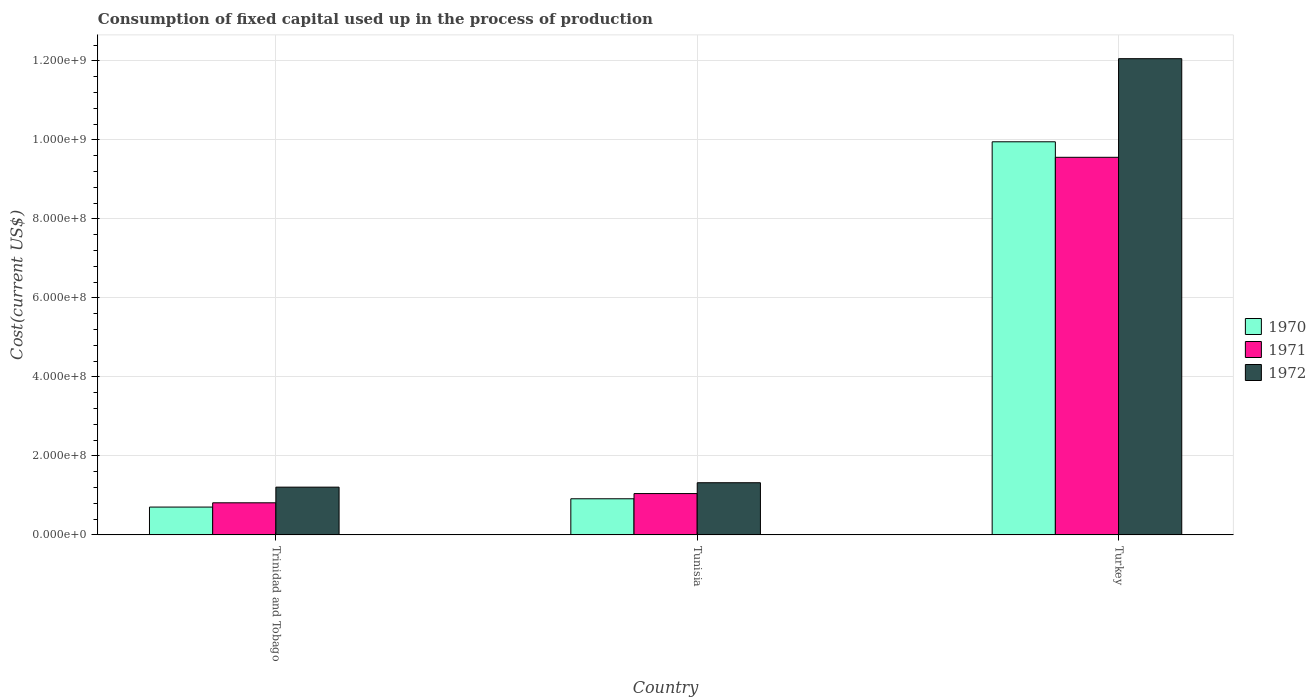How many different coloured bars are there?
Offer a terse response. 3. Are the number of bars on each tick of the X-axis equal?
Make the answer very short. Yes. How many bars are there on the 2nd tick from the right?
Provide a short and direct response. 3. What is the label of the 2nd group of bars from the left?
Your answer should be compact. Tunisia. What is the amount consumed in the process of production in 1972 in Turkey?
Your answer should be compact. 1.21e+09. Across all countries, what is the maximum amount consumed in the process of production in 1972?
Your response must be concise. 1.21e+09. Across all countries, what is the minimum amount consumed in the process of production in 1972?
Offer a very short reply. 1.21e+08. In which country was the amount consumed in the process of production in 1972 minimum?
Provide a succinct answer. Trinidad and Tobago. What is the total amount consumed in the process of production in 1971 in the graph?
Give a very brief answer. 1.14e+09. What is the difference between the amount consumed in the process of production in 1972 in Trinidad and Tobago and that in Tunisia?
Offer a very short reply. -1.12e+07. What is the difference between the amount consumed in the process of production in 1971 in Trinidad and Tobago and the amount consumed in the process of production in 1970 in Tunisia?
Make the answer very short. -1.02e+07. What is the average amount consumed in the process of production in 1970 per country?
Provide a short and direct response. 3.86e+08. What is the difference between the amount consumed in the process of production of/in 1972 and amount consumed in the process of production of/in 1970 in Tunisia?
Provide a short and direct response. 4.06e+07. In how many countries, is the amount consumed in the process of production in 1972 greater than 1160000000 US$?
Your answer should be compact. 1. What is the ratio of the amount consumed in the process of production in 1971 in Trinidad and Tobago to that in Turkey?
Your answer should be compact. 0.09. What is the difference between the highest and the second highest amount consumed in the process of production in 1972?
Provide a succinct answer. 1.08e+09. What is the difference between the highest and the lowest amount consumed in the process of production in 1970?
Offer a very short reply. 9.25e+08. Is the sum of the amount consumed in the process of production in 1971 in Trinidad and Tobago and Tunisia greater than the maximum amount consumed in the process of production in 1972 across all countries?
Give a very brief answer. No. What does the 3rd bar from the left in Trinidad and Tobago represents?
Provide a succinct answer. 1972. Are all the bars in the graph horizontal?
Your response must be concise. No. Are the values on the major ticks of Y-axis written in scientific E-notation?
Offer a very short reply. Yes. Does the graph contain any zero values?
Give a very brief answer. No. Does the graph contain grids?
Offer a very short reply. Yes. Where does the legend appear in the graph?
Ensure brevity in your answer.  Center right. How many legend labels are there?
Offer a terse response. 3. What is the title of the graph?
Make the answer very short. Consumption of fixed capital used up in the process of production. What is the label or title of the Y-axis?
Make the answer very short. Cost(current US$). What is the Cost(current US$) of 1970 in Trinidad and Tobago?
Your response must be concise. 7.05e+07. What is the Cost(current US$) of 1971 in Trinidad and Tobago?
Make the answer very short. 8.13e+07. What is the Cost(current US$) in 1972 in Trinidad and Tobago?
Your answer should be compact. 1.21e+08. What is the Cost(current US$) in 1970 in Tunisia?
Offer a very short reply. 9.14e+07. What is the Cost(current US$) of 1971 in Tunisia?
Your response must be concise. 1.05e+08. What is the Cost(current US$) in 1972 in Tunisia?
Make the answer very short. 1.32e+08. What is the Cost(current US$) of 1970 in Turkey?
Give a very brief answer. 9.95e+08. What is the Cost(current US$) in 1971 in Turkey?
Provide a short and direct response. 9.56e+08. What is the Cost(current US$) in 1972 in Turkey?
Offer a terse response. 1.21e+09. Across all countries, what is the maximum Cost(current US$) in 1970?
Your answer should be very brief. 9.95e+08. Across all countries, what is the maximum Cost(current US$) in 1971?
Make the answer very short. 9.56e+08. Across all countries, what is the maximum Cost(current US$) of 1972?
Provide a short and direct response. 1.21e+09. Across all countries, what is the minimum Cost(current US$) in 1970?
Your response must be concise. 7.05e+07. Across all countries, what is the minimum Cost(current US$) of 1971?
Offer a terse response. 8.13e+07. Across all countries, what is the minimum Cost(current US$) of 1972?
Your answer should be very brief. 1.21e+08. What is the total Cost(current US$) in 1970 in the graph?
Give a very brief answer. 1.16e+09. What is the total Cost(current US$) of 1971 in the graph?
Your answer should be compact. 1.14e+09. What is the total Cost(current US$) of 1972 in the graph?
Offer a terse response. 1.46e+09. What is the difference between the Cost(current US$) of 1970 in Trinidad and Tobago and that in Tunisia?
Give a very brief answer. -2.10e+07. What is the difference between the Cost(current US$) in 1971 in Trinidad and Tobago and that in Tunisia?
Offer a very short reply. -2.34e+07. What is the difference between the Cost(current US$) in 1972 in Trinidad and Tobago and that in Tunisia?
Your answer should be very brief. -1.12e+07. What is the difference between the Cost(current US$) of 1970 in Trinidad and Tobago and that in Turkey?
Provide a succinct answer. -9.25e+08. What is the difference between the Cost(current US$) of 1971 in Trinidad and Tobago and that in Turkey?
Your response must be concise. -8.75e+08. What is the difference between the Cost(current US$) in 1972 in Trinidad and Tobago and that in Turkey?
Keep it short and to the point. -1.08e+09. What is the difference between the Cost(current US$) in 1970 in Tunisia and that in Turkey?
Keep it short and to the point. -9.04e+08. What is the difference between the Cost(current US$) of 1971 in Tunisia and that in Turkey?
Your response must be concise. -8.51e+08. What is the difference between the Cost(current US$) in 1972 in Tunisia and that in Turkey?
Offer a terse response. -1.07e+09. What is the difference between the Cost(current US$) in 1970 in Trinidad and Tobago and the Cost(current US$) in 1971 in Tunisia?
Keep it short and to the point. -3.42e+07. What is the difference between the Cost(current US$) of 1970 in Trinidad and Tobago and the Cost(current US$) of 1972 in Tunisia?
Keep it short and to the point. -6.16e+07. What is the difference between the Cost(current US$) of 1971 in Trinidad and Tobago and the Cost(current US$) of 1972 in Tunisia?
Your response must be concise. -5.08e+07. What is the difference between the Cost(current US$) in 1970 in Trinidad and Tobago and the Cost(current US$) in 1971 in Turkey?
Provide a short and direct response. -8.86e+08. What is the difference between the Cost(current US$) in 1970 in Trinidad and Tobago and the Cost(current US$) in 1972 in Turkey?
Ensure brevity in your answer.  -1.14e+09. What is the difference between the Cost(current US$) in 1971 in Trinidad and Tobago and the Cost(current US$) in 1972 in Turkey?
Your response must be concise. -1.12e+09. What is the difference between the Cost(current US$) of 1970 in Tunisia and the Cost(current US$) of 1971 in Turkey?
Offer a very short reply. -8.65e+08. What is the difference between the Cost(current US$) in 1970 in Tunisia and the Cost(current US$) in 1972 in Turkey?
Your answer should be compact. -1.11e+09. What is the difference between the Cost(current US$) in 1971 in Tunisia and the Cost(current US$) in 1972 in Turkey?
Your response must be concise. -1.10e+09. What is the average Cost(current US$) in 1970 per country?
Ensure brevity in your answer.  3.86e+08. What is the average Cost(current US$) in 1971 per country?
Keep it short and to the point. 3.81e+08. What is the average Cost(current US$) in 1972 per country?
Your answer should be compact. 4.86e+08. What is the difference between the Cost(current US$) of 1970 and Cost(current US$) of 1971 in Trinidad and Tobago?
Make the answer very short. -1.08e+07. What is the difference between the Cost(current US$) of 1970 and Cost(current US$) of 1972 in Trinidad and Tobago?
Your response must be concise. -5.04e+07. What is the difference between the Cost(current US$) in 1971 and Cost(current US$) in 1972 in Trinidad and Tobago?
Make the answer very short. -3.96e+07. What is the difference between the Cost(current US$) in 1970 and Cost(current US$) in 1971 in Tunisia?
Provide a short and direct response. -1.32e+07. What is the difference between the Cost(current US$) of 1970 and Cost(current US$) of 1972 in Tunisia?
Ensure brevity in your answer.  -4.06e+07. What is the difference between the Cost(current US$) of 1971 and Cost(current US$) of 1972 in Tunisia?
Ensure brevity in your answer.  -2.75e+07. What is the difference between the Cost(current US$) of 1970 and Cost(current US$) of 1971 in Turkey?
Keep it short and to the point. 3.93e+07. What is the difference between the Cost(current US$) of 1970 and Cost(current US$) of 1972 in Turkey?
Provide a succinct answer. -2.10e+08. What is the difference between the Cost(current US$) of 1971 and Cost(current US$) of 1972 in Turkey?
Your answer should be very brief. -2.50e+08. What is the ratio of the Cost(current US$) of 1970 in Trinidad and Tobago to that in Tunisia?
Your answer should be very brief. 0.77. What is the ratio of the Cost(current US$) in 1971 in Trinidad and Tobago to that in Tunisia?
Provide a succinct answer. 0.78. What is the ratio of the Cost(current US$) of 1972 in Trinidad and Tobago to that in Tunisia?
Your response must be concise. 0.92. What is the ratio of the Cost(current US$) of 1970 in Trinidad and Tobago to that in Turkey?
Your answer should be compact. 0.07. What is the ratio of the Cost(current US$) in 1971 in Trinidad and Tobago to that in Turkey?
Offer a very short reply. 0.09. What is the ratio of the Cost(current US$) of 1972 in Trinidad and Tobago to that in Turkey?
Offer a very short reply. 0.1. What is the ratio of the Cost(current US$) in 1970 in Tunisia to that in Turkey?
Offer a very short reply. 0.09. What is the ratio of the Cost(current US$) in 1971 in Tunisia to that in Turkey?
Give a very brief answer. 0.11. What is the ratio of the Cost(current US$) of 1972 in Tunisia to that in Turkey?
Ensure brevity in your answer.  0.11. What is the difference between the highest and the second highest Cost(current US$) of 1970?
Offer a very short reply. 9.04e+08. What is the difference between the highest and the second highest Cost(current US$) in 1971?
Make the answer very short. 8.51e+08. What is the difference between the highest and the second highest Cost(current US$) of 1972?
Offer a very short reply. 1.07e+09. What is the difference between the highest and the lowest Cost(current US$) in 1970?
Give a very brief answer. 9.25e+08. What is the difference between the highest and the lowest Cost(current US$) of 1971?
Your answer should be very brief. 8.75e+08. What is the difference between the highest and the lowest Cost(current US$) in 1972?
Provide a succinct answer. 1.08e+09. 